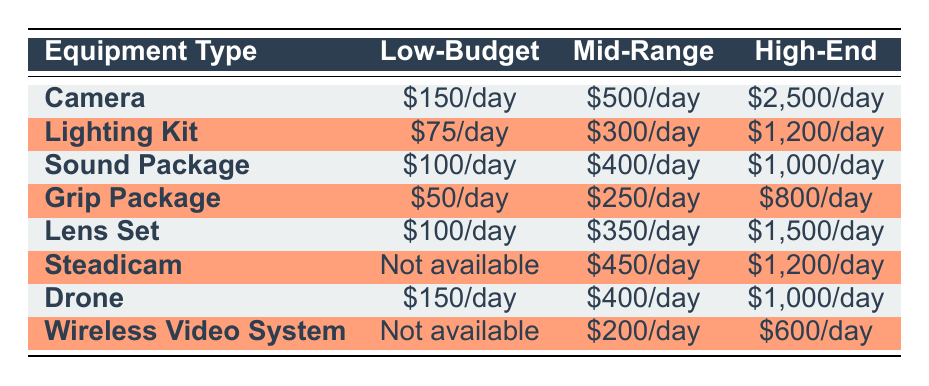What is the cost of renting a sound package for a low-budget production? The table indicates that the cost for a low-budget sound package is $100 per day.
Answer: $100/day What is the daily rental cost of a camera for a mid-range production? From the table, the rental cost for a camera in a mid-range production is $500 per day.
Answer: $500/day Is a wireless video system available for a low-budget production? The table shows that a wireless video system is listed as "Not available" for low-budget production, which means it cannot be rented.
Answer: No What is the difference in cost to rent a lighting kit between mid-range and high-end productions? The cost for a lighting kit is $300 per day for mid-range and $1,200 per day for high-end productions. The difference is $1,200 - $300 = $900.
Answer: $900 Which equipment type has the highest rental cost for a high-end production? By reviewing the high-end production costs in the table, the camera costs $2,500 per day, which is the highest among all equipment types.
Answer: Camera at $2,500/day If you were to rent all equipment types for a low-budget production, what would be the total daily cost? Adding the costs for all equipment types for low-budget productions: $150 (Camera) + $75 (Lighting Kit) + $100 (Sound Package) + $50 (Grip Package) + $100 (Lens Set) + $0 (Steadicam) + $150 (Drone) + $0 (Wireless Video System) = $625 total.
Answer: $625 Are there any sound packages available for high-end productions? The table lists the sound package availability for high-end production at $1,000 per day, which confirms that it is available.
Answer: Yes What is the average cost of renting a lens set across all production scales? The costs for a lens set are $100 for low-budget, $350 for mid-range, and $1,500 for high-end. Adding these gives $100 + $350 + $1,500 = $1,950. There are three data points, so the average is $1,950/3 = $650.
Answer: $650 What is the total cost difference for renting a drone between low-budget and high-end productions? The low-budget cost for a drone is $150 and the high-end cost is $1,000. The difference is $1,000 - $150 = $850.
Answer: $850 